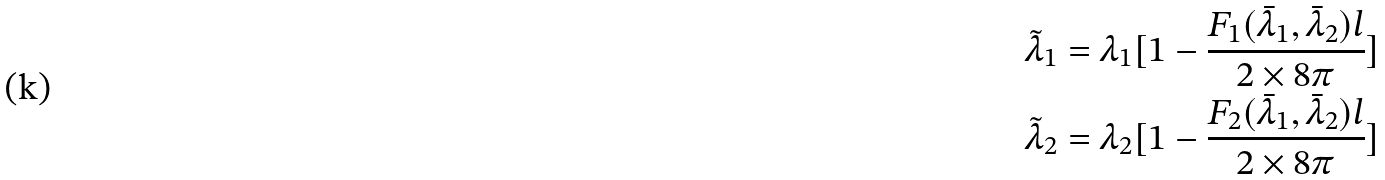<formula> <loc_0><loc_0><loc_500><loc_500>& \tilde { \lambda } _ { 1 } = \lambda _ { 1 } [ 1 - \frac { F _ { 1 } ( \bar { \lambda } _ { 1 } , \bar { \lambda } _ { 2 } ) l } { 2 \times 8 \pi } ] \\ & \tilde { \lambda } _ { 2 } = \lambda _ { 2 } [ 1 - \frac { F _ { 2 } ( \bar { \lambda } _ { 1 } , \bar { \lambda } _ { 2 } ) l } { 2 \times 8 \pi } ]</formula> 